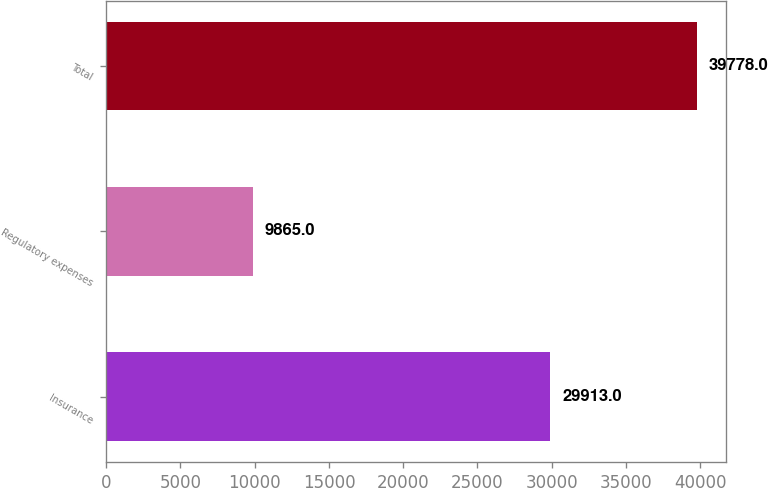<chart> <loc_0><loc_0><loc_500><loc_500><bar_chart><fcel>Insurance<fcel>Regulatory expenses<fcel>Total<nl><fcel>29913<fcel>9865<fcel>39778<nl></chart> 